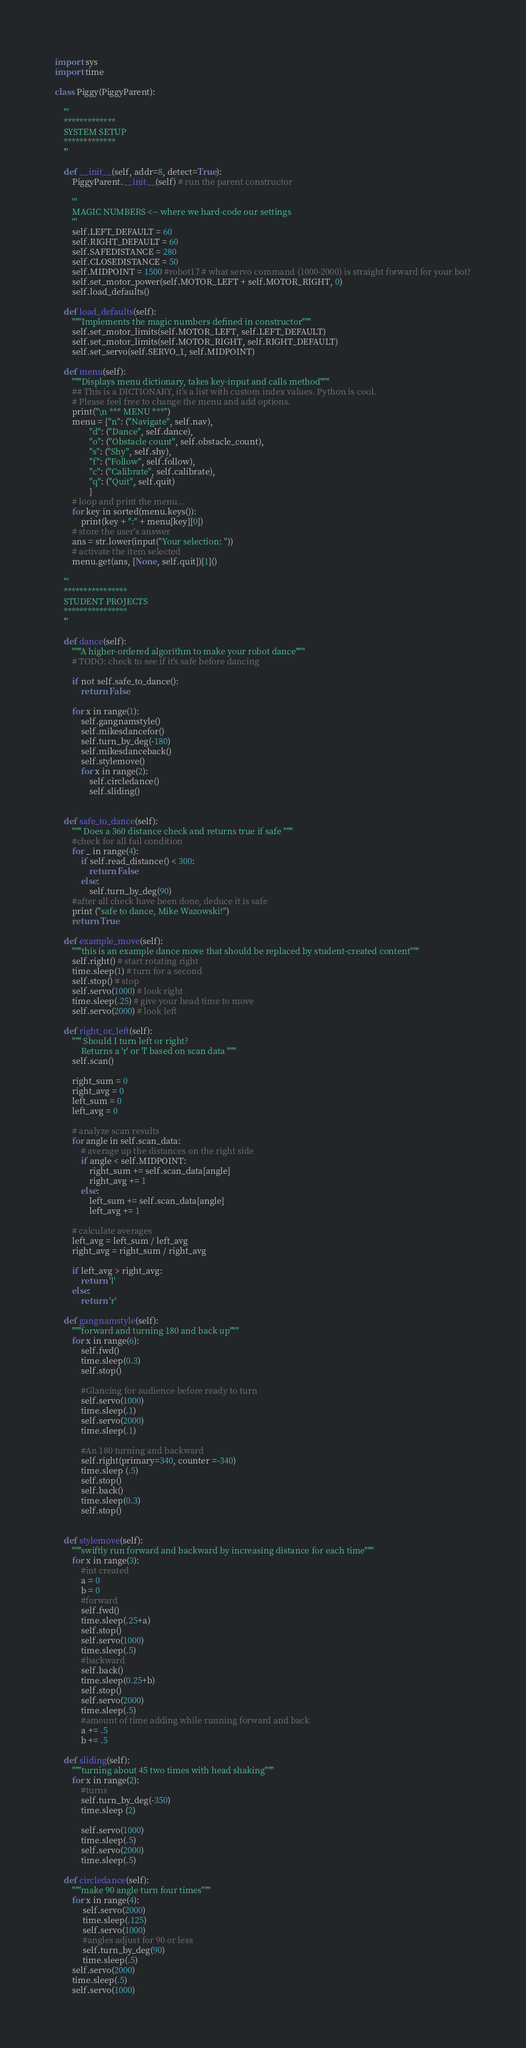<code> <loc_0><loc_0><loc_500><loc_500><_Python_>import sys
import time

class Piggy(PiggyParent):

    '''
    *************
    SYSTEM SETUP
    *************
    '''

    def __init__(self, addr=8, detect=True):
        PiggyParent.__init__(self) # run the parent constructor

        ''' 
        MAGIC NUMBERS <-- where we hard-code our settings
        '''
        self.LEFT_DEFAULT = 60
        self.RIGHT_DEFAULT = 60
        self.SAFEDISTANCE = 280
        self.CLOSEDISTANCE = 50
        self.MIDPOINT = 1500 #robot17 # what servo command (1000-2000) is straight forward for your bot?
        self.set_motor_power(self.MOTOR_LEFT + self.MOTOR_RIGHT, 0)
        self.load_defaults()
        
    def load_defaults(self):
        """Implements the magic numbers defined in constructor"""
        self.set_motor_limits(self.MOTOR_LEFT, self.LEFT_DEFAULT)
        self.set_motor_limits(self.MOTOR_RIGHT, self.RIGHT_DEFAULT)
        self.set_servo(self.SERVO_1, self.MIDPOINT)
        
    def menu(self):
        """Displays menu dictionary, takes key-input and calls method"""
        ## This is a DICTIONARY, it's a list with custom index values. Python is cool.
        # Please feel free to change the menu and add options.
        print("\n *** MENU ***") 
        menu = {"n": ("Navigate", self.nav),
                "d": ("Dance", self.dance),
                "o": ("Obstacle count", self.obstacle_count),
                "s": ("Shy", self.shy),
                "f": ("Follow", self.follow),
                "c": ("Calibrate", self.calibrate),
                "q": ("Quit", self.quit)
                }
        # loop and print the menu...
        for key in sorted(menu.keys()):
            print(key + ":" + menu[key][0])
        # store the user's answer
        ans = str.lower(input("Your selection: "))
        # activate the item selected
        menu.get(ans, [None, self.quit])[1]()

    '''
    ****************
    STUDENT PROJECTS
    ****************
    '''

    def dance(self):
        """A higher-ordered algorithm to make your robot dance"""
        # TODO: check to see if it's safe before dancing

        if not self.safe_to_dance():
            return False
        
        for x in range(1):
            self.gangnamstyle()
            self.mikesdancefor()
            self.turn_by_deg(-180)
            self.mikesdanceback()
            self.stylemove()
            for x in range(2):
                self.circledance()
                self.sliding()


    def safe_to_dance(self):
        """ Does a 360 distance check and returns true if safe """
        #check for all fail condition
        for _ in range(4):
            if self.read_distance() < 300:
                return False
            else:
                self.turn_by_deg(90)
        #after all check have been done, deduce it is safe
        print ("safe to dance, Mike Wazowski!")
        return True

    def example_move(self):
        """this is an example dance move that should be replaced by student-created content"""
        self.right() # start rotating right
        time.sleep(1) # turn for a second
        self.stop() # stop
        self.servo(1000) # look right
        time.sleep(.25) # give your head time to move
        self.servo(2000) # look left

    def right_or_left(self):
        """ Should I turn left or right? 
            Returns a 'r' or 'l' based on scan data """
        self.scan()
        
        right_sum = 0
        right_avg = 0
        left_sum = 0
        left_avg = 0
        
        # analyze scan results
        for angle in self.scan_data:
            # average up the distances on the right side
            if angle < self.MIDPOINT:
                right_sum += self.scan_data[angle]
                right_avg += 1
            else:
                left_sum += self.scan_data[angle]
                left_avg += 1
        
        # calculate averages
        left_avg = left_sum / left_avg
        right_avg = right_sum / right_avg

        if left_avg > right_avg: 
            return 'l'
        else:
            return 'r'
   
    def gangnamstyle(self):
        """forward and turning 180 and back up"""
        for x in range(6):
            self.fwd()
            time.sleep(0.3)
            self.stop()
            
            #Glancing for audience before ready to turn
            self.servo(1000)
            time.sleep(.1) 
            self.servo(2000)
            time.sleep(.1) 
            
            #An 180 turning and backward
            self.right(primary=340, counter =-340)
            time.sleep (.5)
            self.stop()
            self.back()
            time.sleep(0.3)
            self.stop()
            

    def stylemove(self):
        """swiftly run forward and backward by increasing distance for each time"""
        for x in range(3):
            #int created
            a = 0
            b = 0
            #forward
            self.fwd()
            time.sleep(.25+a)
            self.stop()
            self.servo(1000)
            time.sleep(.5)
            #backward
            self.back()
            time.sleep(0.25+b)
            self.stop()
            self.servo(2000)
            time.sleep(.5)
            #amount of time adding while running forward and back
            a += .5
            b += .5

    def sliding(self):
        """turning about 45 two times with head shaking"""
        for x in range(2):
            #turns
            self.turn_by_deg(-350)
            time.sleep (2)  

            self.servo(1000) 
            time.sleep(.5)
            self.servo(2000)
            time.sleep(.5)

    def circledance(self):
        """make 90 angle turn four times"""
        for x in range(4):
             self.servo(2000) 
             time.sleep(.125)
             self.servo(1000)
             #angles adjust for 90 or less
             self.turn_by_deg(90)
             time.sleep(.5)       
        self.servo(2000) 
        time.sleep(.5)
        self.servo(1000)</code> 